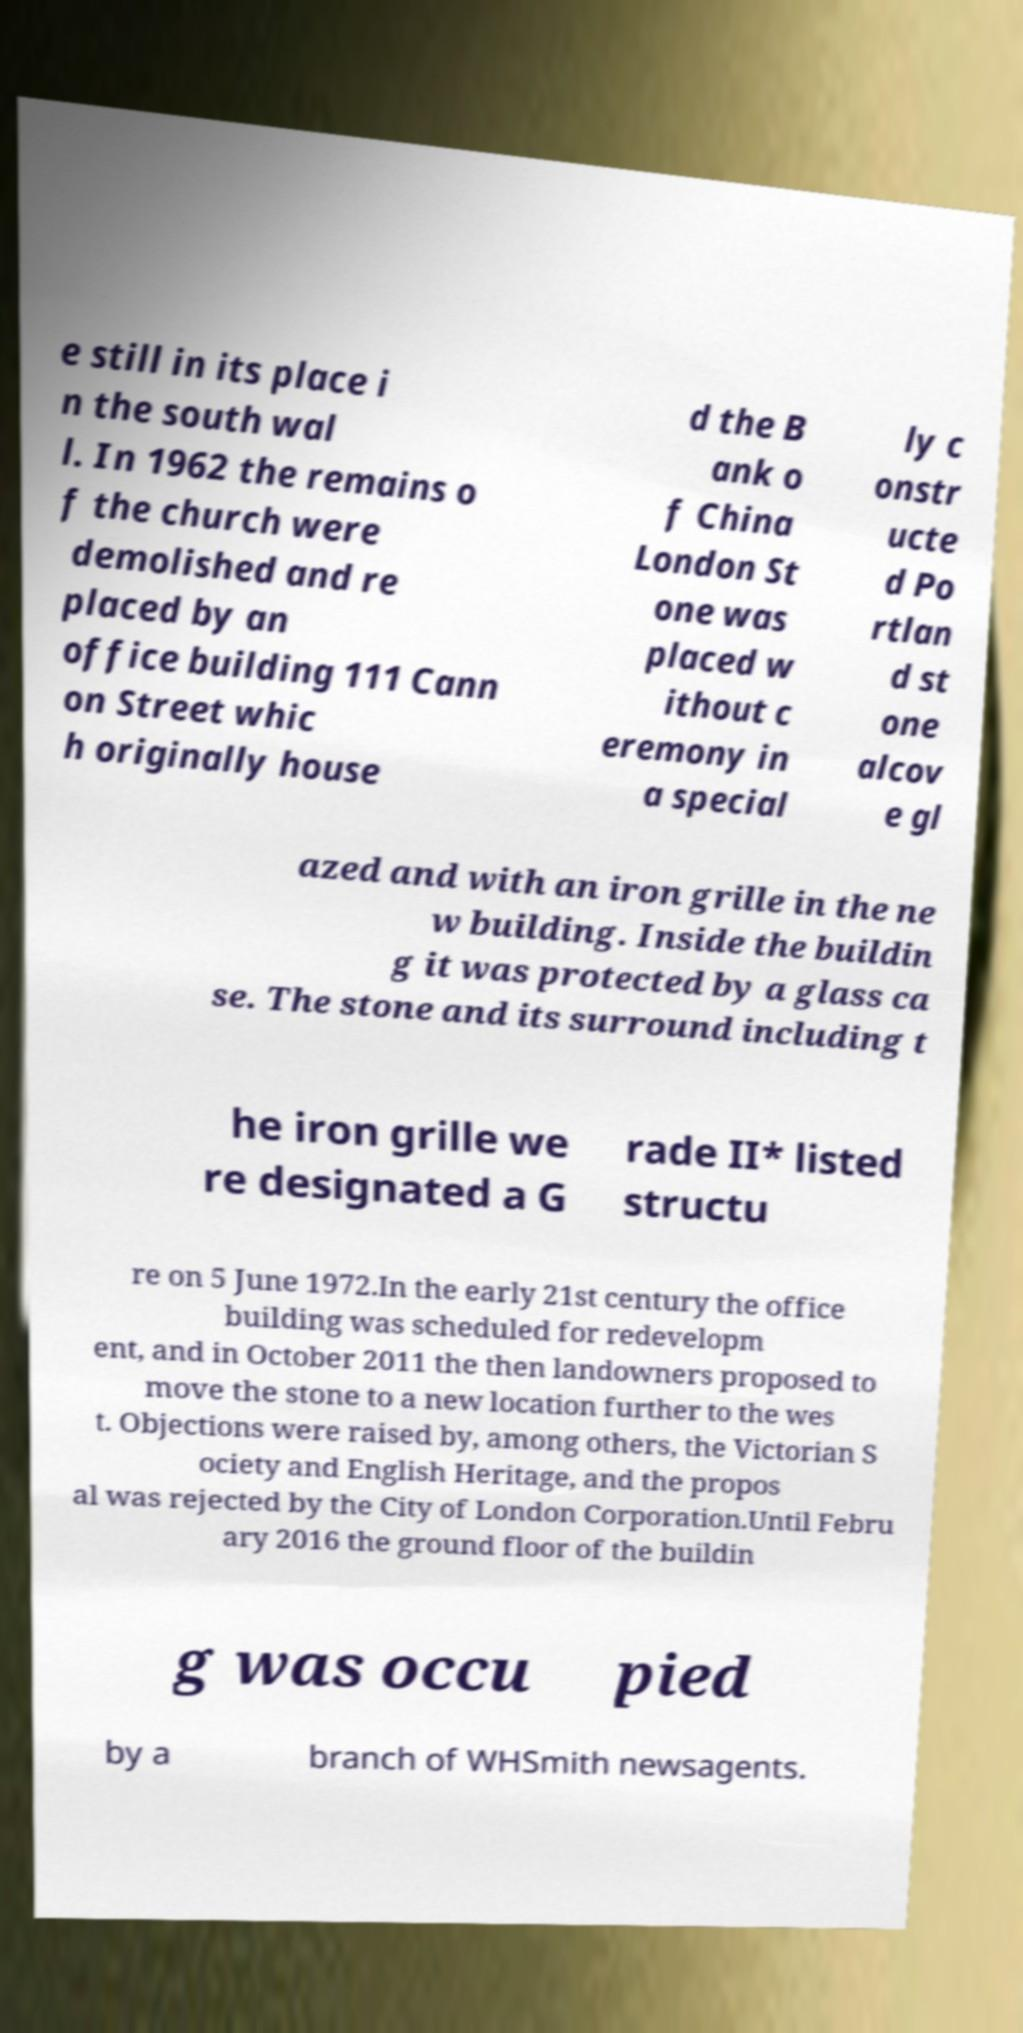There's text embedded in this image that I need extracted. Can you transcribe it verbatim? e still in its place i n the south wal l. In 1962 the remains o f the church were demolished and re placed by an office building 111 Cann on Street whic h originally house d the B ank o f China London St one was placed w ithout c eremony in a special ly c onstr ucte d Po rtlan d st one alcov e gl azed and with an iron grille in the ne w building. Inside the buildin g it was protected by a glass ca se. The stone and its surround including t he iron grille we re designated a G rade II* listed structu re on 5 June 1972.In the early 21st century the office building was scheduled for redevelopm ent, and in October 2011 the then landowners proposed to move the stone to a new location further to the wes t. Objections were raised by, among others, the Victorian S ociety and English Heritage, and the propos al was rejected by the City of London Corporation.Until Febru ary 2016 the ground floor of the buildin g was occu pied by a branch of WHSmith newsagents. 